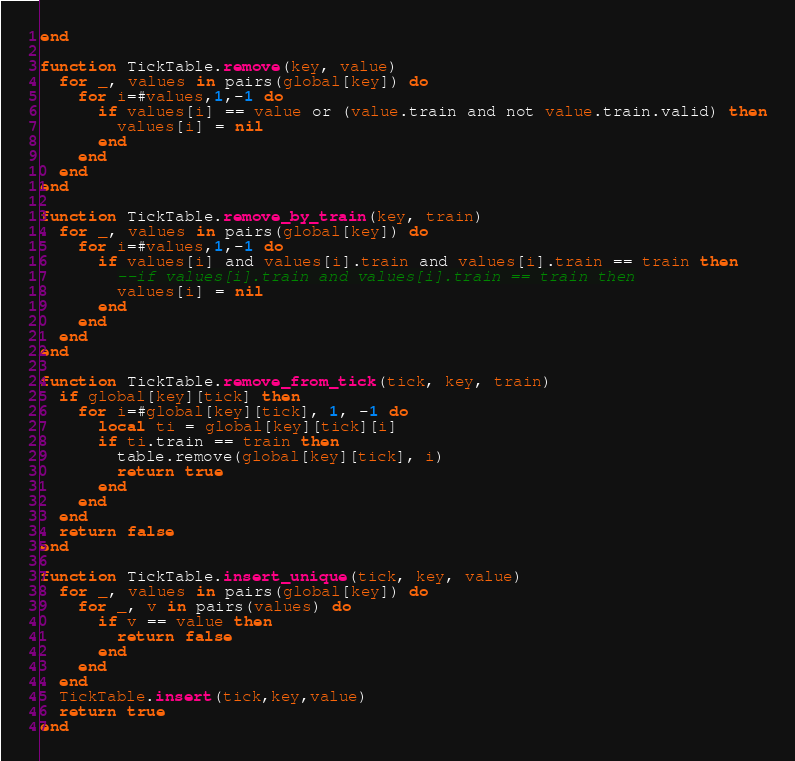<code> <loc_0><loc_0><loc_500><loc_500><_Lua_>end

function TickTable.remove(key, value)
  for _, values in pairs(global[key]) do
    for i=#values,1,-1 do
      if values[i] == value or (value.train and not value.train.valid) then
        values[i] = nil
      end
    end
  end
end

function TickTable.remove_by_train(key, train)
  for _, values in pairs(global[key]) do
    for i=#values,1,-1 do
      if values[i] and values[i].train and values[i].train == train then
        --if values[i].train and values[i].train == train then
        values[i] = nil
      end
    end
  end
end

function TickTable.remove_from_tick(tick, key, train)
  if global[key][tick] then
    for i=#global[key][tick], 1, -1 do
      local ti = global[key][tick][i]
      if ti.train == train then
        table.remove(global[key][tick], i)
        return true
      end
    end
  end
  return false
end

function TickTable.insert_unique(tick, key, value)
  for _, values in pairs(global[key]) do
    for _, v in pairs(values) do
      if v == value then
        return false
      end
    end
  end
  TickTable.insert(tick,key,value)
  return true
end
</code> 